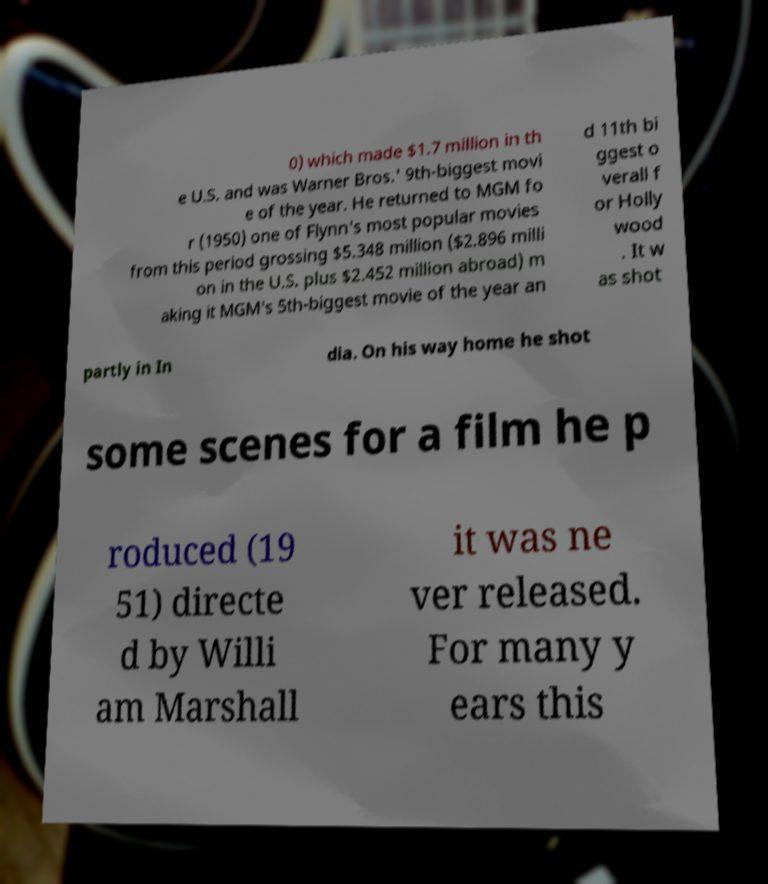Could you assist in decoding the text presented in this image and type it out clearly? 0) which made $1.7 million in th e U.S. and was Warner Bros.' 9th-biggest movi e of the year. He returned to MGM fo r (1950) one of Flynn's most popular movies from this period grossing $5.348 million ($2.896 milli on in the U.S. plus $2.452 million abroad) m aking it MGM's 5th-biggest movie of the year an d 11th bi ggest o verall f or Holly wood . It w as shot partly in In dia. On his way home he shot some scenes for a film he p roduced (19 51) directe d by Willi am Marshall it was ne ver released. For many y ears this 